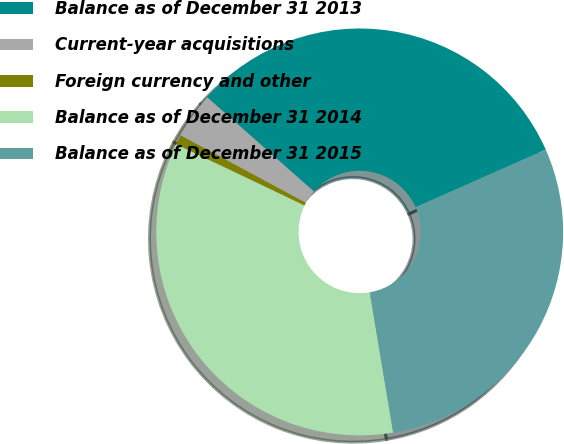Convert chart to OTSL. <chart><loc_0><loc_0><loc_500><loc_500><pie_chart><fcel>Balance as of December 31 2013<fcel>Current-year acquisitions<fcel>Foreign currency and other<fcel>Balance as of December 31 2014<fcel>Balance as of December 31 2015<nl><fcel>31.86%<fcel>3.64%<fcel>0.77%<fcel>34.73%<fcel>28.99%<nl></chart> 